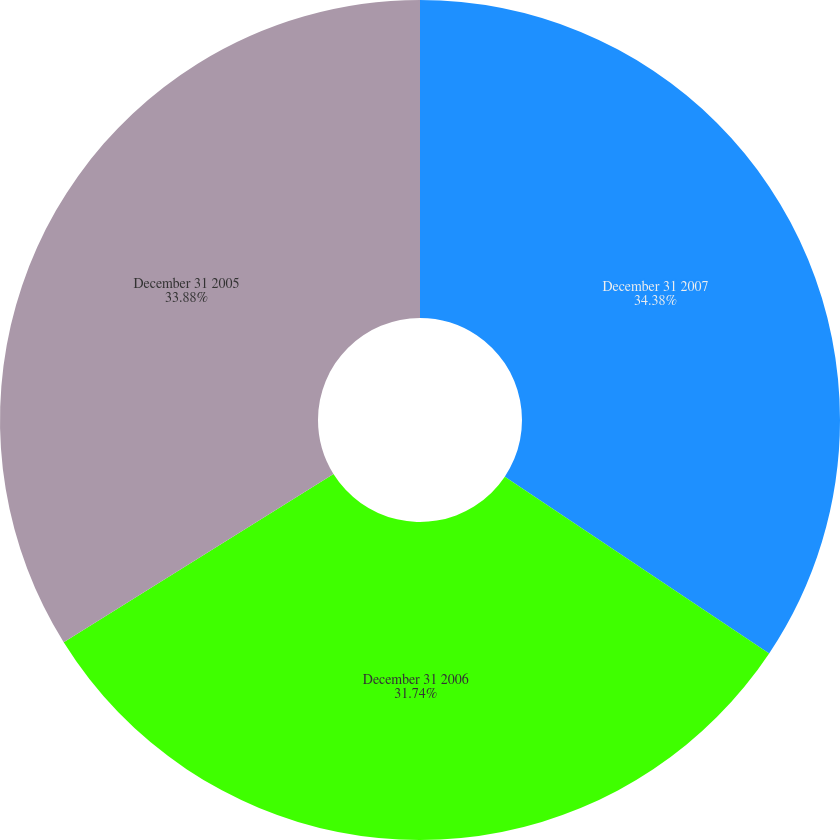Convert chart. <chart><loc_0><loc_0><loc_500><loc_500><pie_chart><fcel>December 31 2007<fcel>December 31 2006<fcel>December 31 2005<nl><fcel>34.38%<fcel>31.74%<fcel>33.88%<nl></chart> 